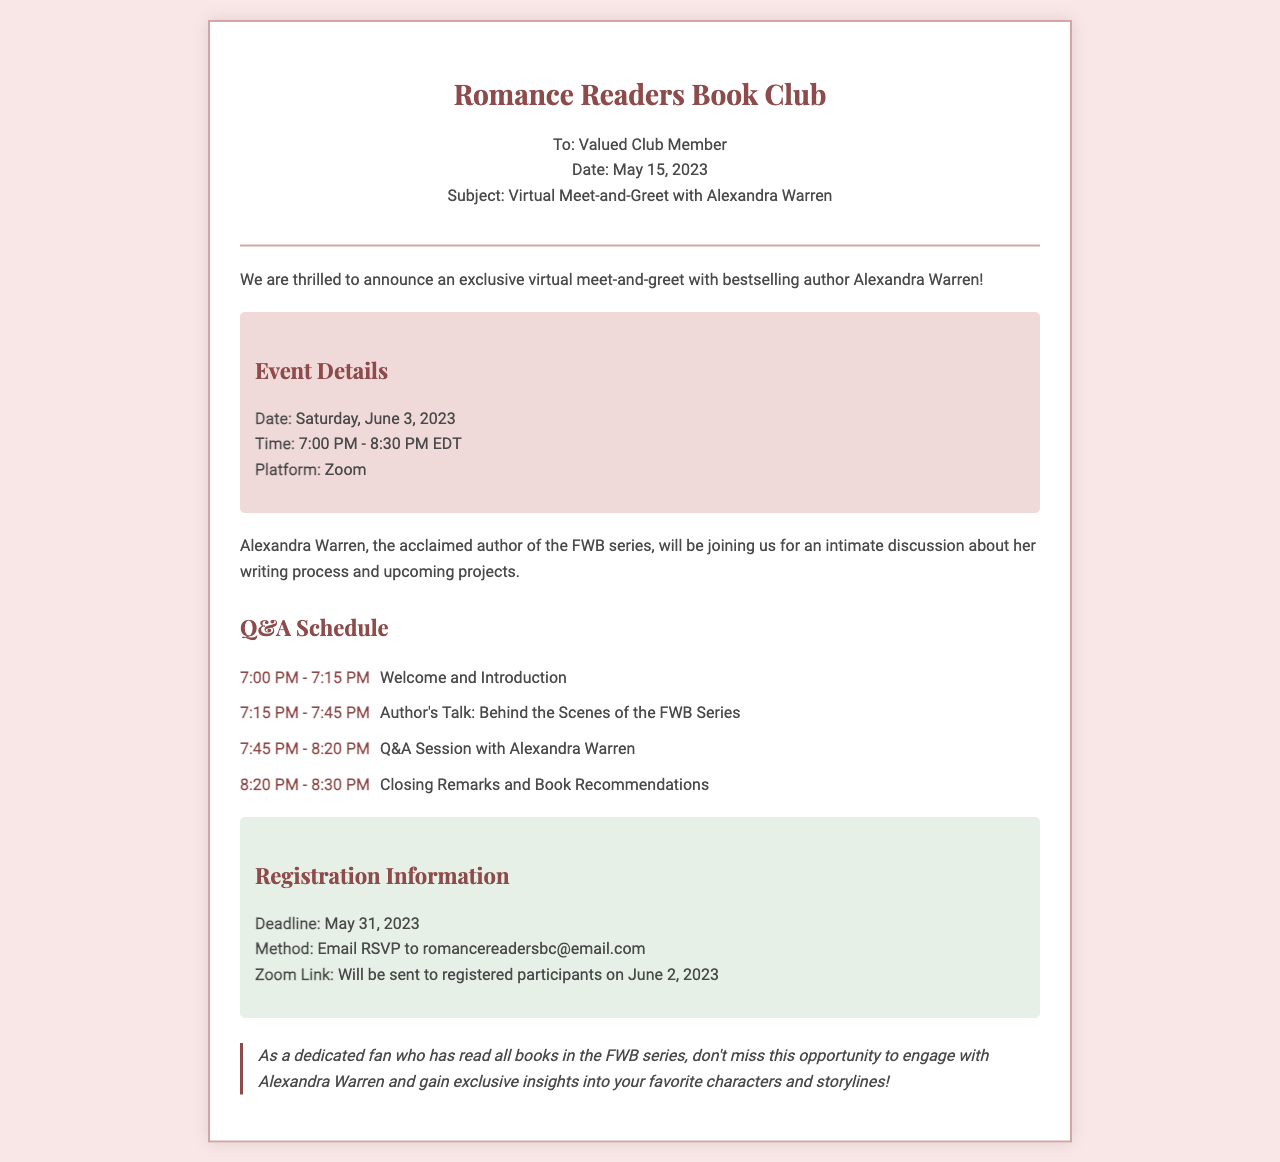what is the date of the virtual meet-and-greet? The date of the event is specified in the document under Event Details.
Answer: Saturday, June 3, 2023 what time does the Q&A session start? The start time of the Q&A session can be found in the schedule section.
Answer: 7:45 PM who is the featured author at the event? The document clearly states the name of the author participating in the meet-and-greet.
Answer: Alexandra Warren what is the registration deadline for the event? The deadline for registration is outlined in the registration information section of the document.
Answer: May 31, 2023 how long is the author's talk scheduled to last? The duration of the author's talk can be determined by the timing in the schedule section.
Answer: 30 minutes what platform will the event be hosted on? The document indicates the platform for the virtual meet-and-greet in the event details.
Answer: Zoom how can participants register for the event? The method of registration is provided in the registration information section.
Answer: Email RSVP to romancereadersbc@email.com what will be discussed during the author's talk? The schedule details what the author will cover during her talk.
Answer: Behind the Scenes of the FWB Series 